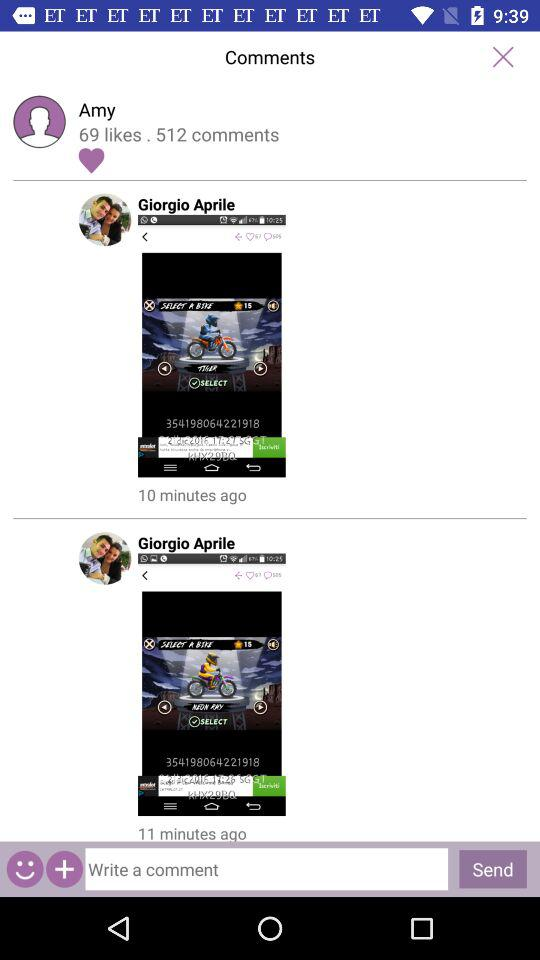What is the count of comments? The count of comments is 512. 